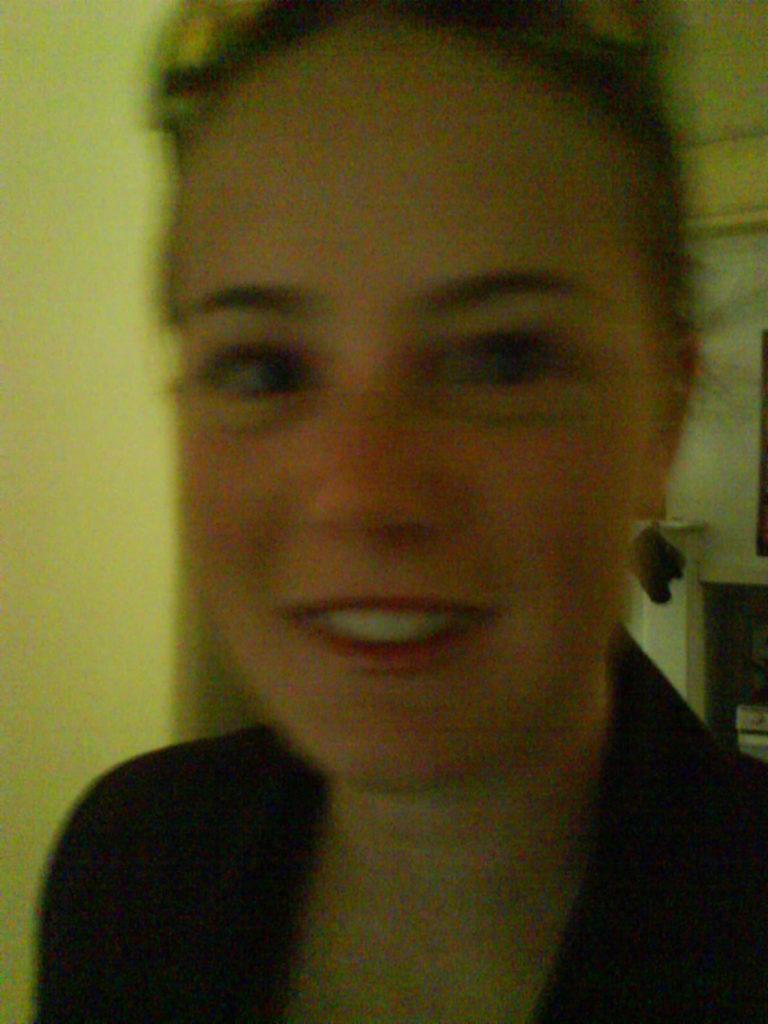Please provide a concise description of this image. In this image there is a lady. In the background there is a wall. 